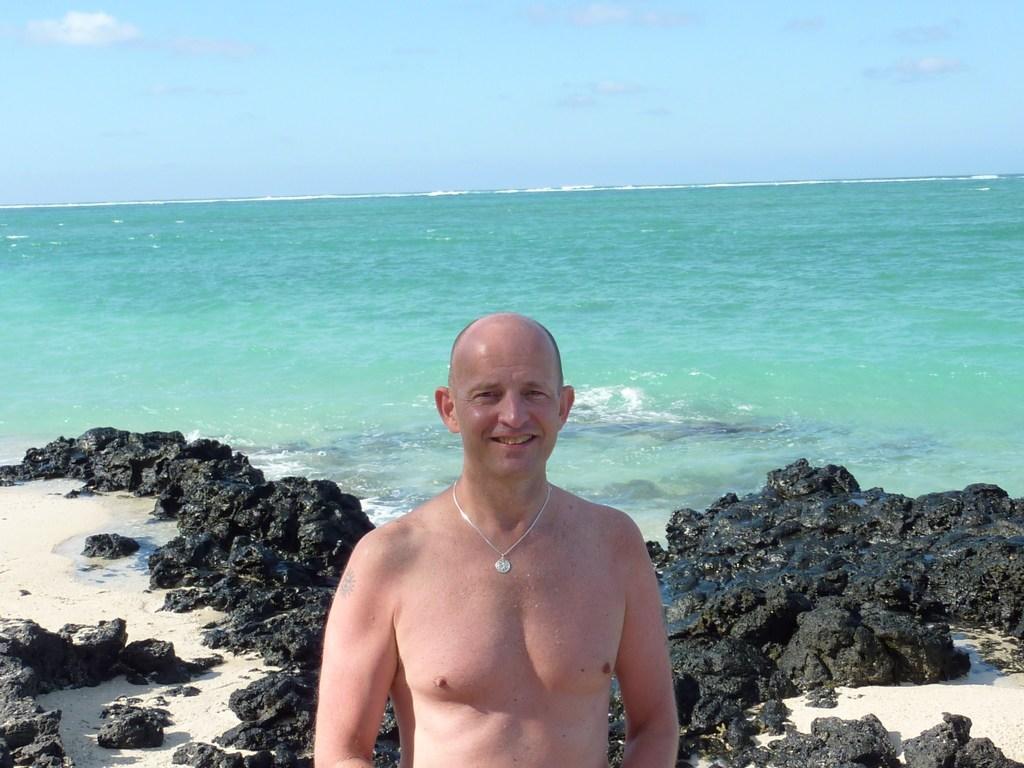How would you summarize this image in a sentence or two? This picture is clicked outside the city. In the foreground there is a man smiling and standing. In the background we can see the rocks and a water body and the sky. 